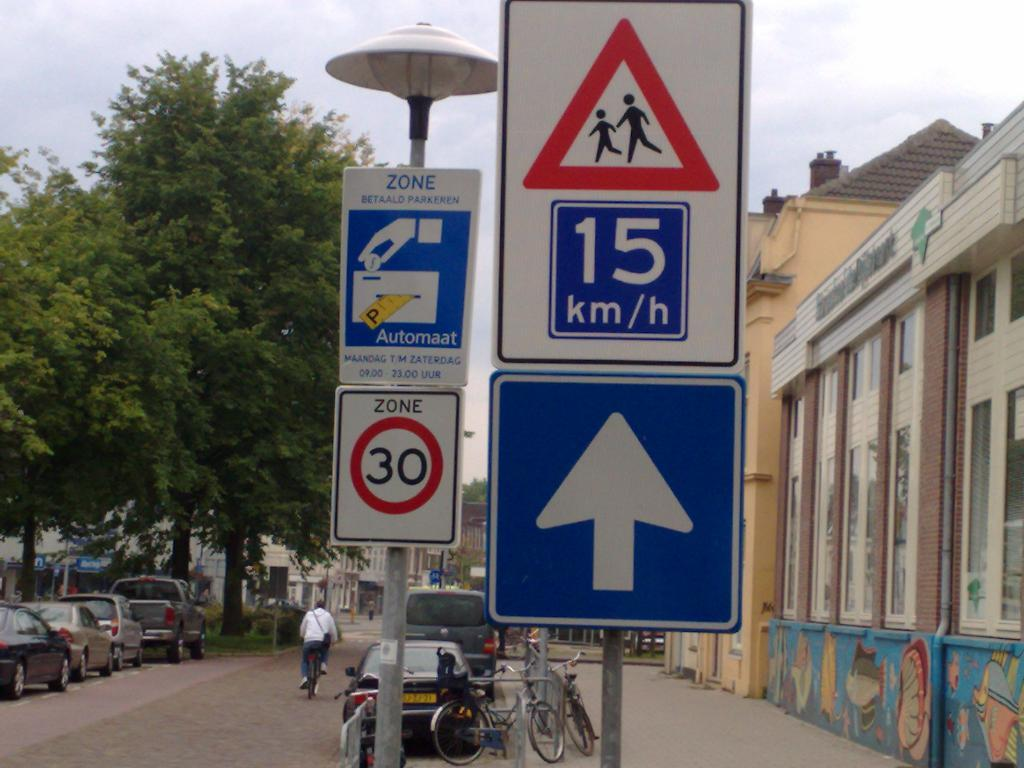<image>
Present a compact description of the photo's key features. a sign for 15 KM/h is on the street 